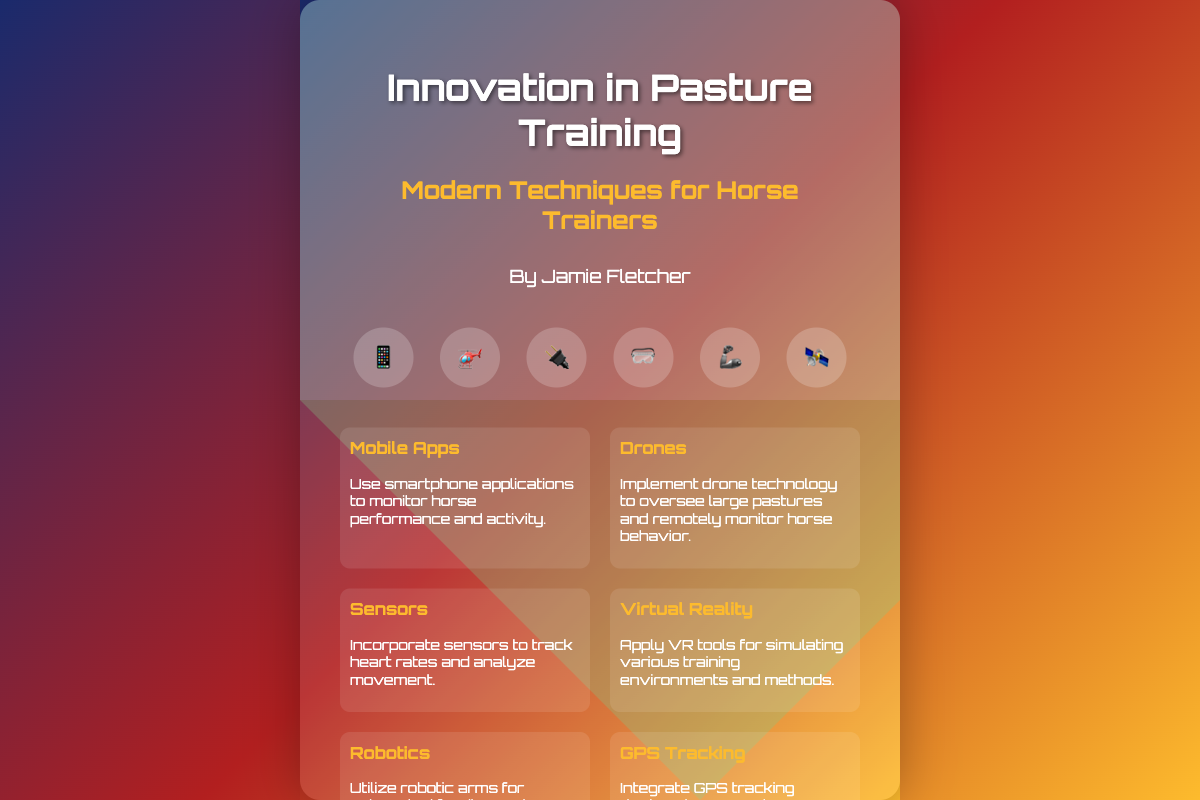What is the title of the book? The title is clearly stated at the top of the document.
Answer: Innovation in Pasture Training: Modern Techniques for Horse Trainers Who is the author? The author's name is provided in the author section of the document.
Answer: Jamie Fletcher How many icons are displayed? The number of icons can be counted in the icons section of the document.
Answer: 6 What training method involves using smartphone applications? This method is explicitly named in the methods section with a description.
Answer: Mobile Apps What tool is used for monitoring large pastures? The document specifies this tool in the methods section for overseeing horse behavior.
Answer: Drones Which method applies sensors for tracking? The specific method is mentioned in the context of movement analysis.
Answer: Sensors What is utilized for automated feeding? The document provides this information under a specific training method.
Answer: Robotics What color is used for the title text? This can be observed in the styles applied to the title text within the design.
Answer: White 